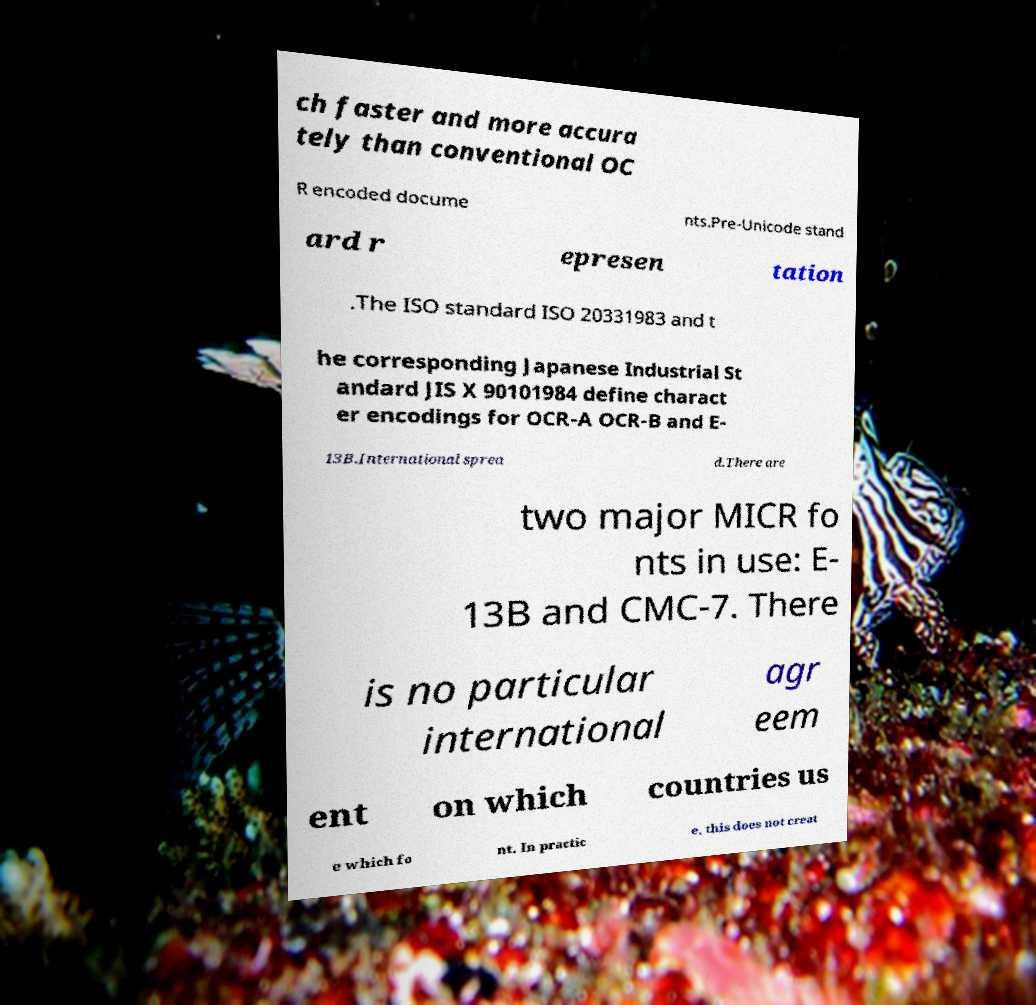Can you accurately transcribe the text from the provided image for me? ch faster and more accura tely than conventional OC R encoded docume nts.Pre-Unicode stand ard r epresen tation .The ISO standard ISO 20331983 and t he corresponding Japanese Industrial St andard JIS X 90101984 define charact er encodings for OCR-A OCR-B and E- 13B.International sprea d.There are two major MICR fo nts in use: E- 13B and CMC-7. There is no particular international agr eem ent on which countries us e which fo nt. In practic e, this does not creat 